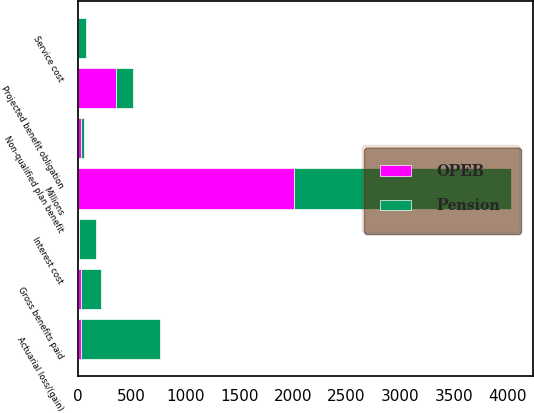Convert chart to OTSL. <chart><loc_0><loc_0><loc_500><loc_500><stacked_bar_chart><ecel><fcel>Millions<fcel>Projected benefit obligation<fcel>Service cost<fcel>Interest cost<fcel>Actuarial loss/(gain)<fcel>Gross benefits paid<fcel>Non-qualified plan benefit<nl><fcel>Pension<fcel>2014<fcel>158<fcel>70<fcel>158<fcel>735<fcel>193<fcel>33<nl><fcel>OPEB<fcel>2014<fcel>354<fcel>2<fcel>14<fcel>33<fcel>25<fcel>25<nl></chart> 